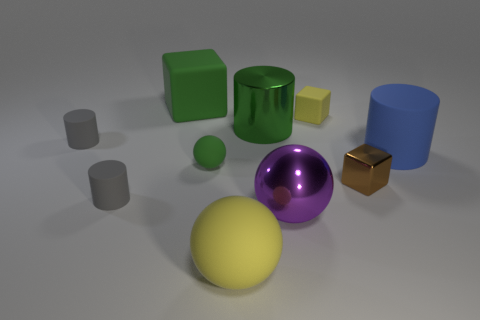How big is the cube left of the yellow block?
Provide a succinct answer. Large. Do the brown metal thing and the green ball have the same size?
Provide a succinct answer. Yes. How many big metal objects are both in front of the brown shiny block and left of the shiny sphere?
Make the answer very short. 0. How many green things are large matte spheres or tiny matte blocks?
Make the answer very short. 0. How many matte objects are either cubes or small brown things?
Your answer should be compact. 2. Are any tiny gray cylinders visible?
Provide a short and direct response. Yes. Is the shape of the blue object the same as the big yellow thing?
Your answer should be compact. No. There is a rubber block that is behind the small rubber object behind the large green shiny object; what number of big yellow spheres are in front of it?
Provide a short and direct response. 1. There is a object that is both behind the brown shiny block and on the right side of the tiny yellow object; what material is it?
Your answer should be very brief. Rubber. There is a large matte thing that is behind the tiny shiny object and left of the big blue thing; what is its color?
Ensure brevity in your answer.  Green. 